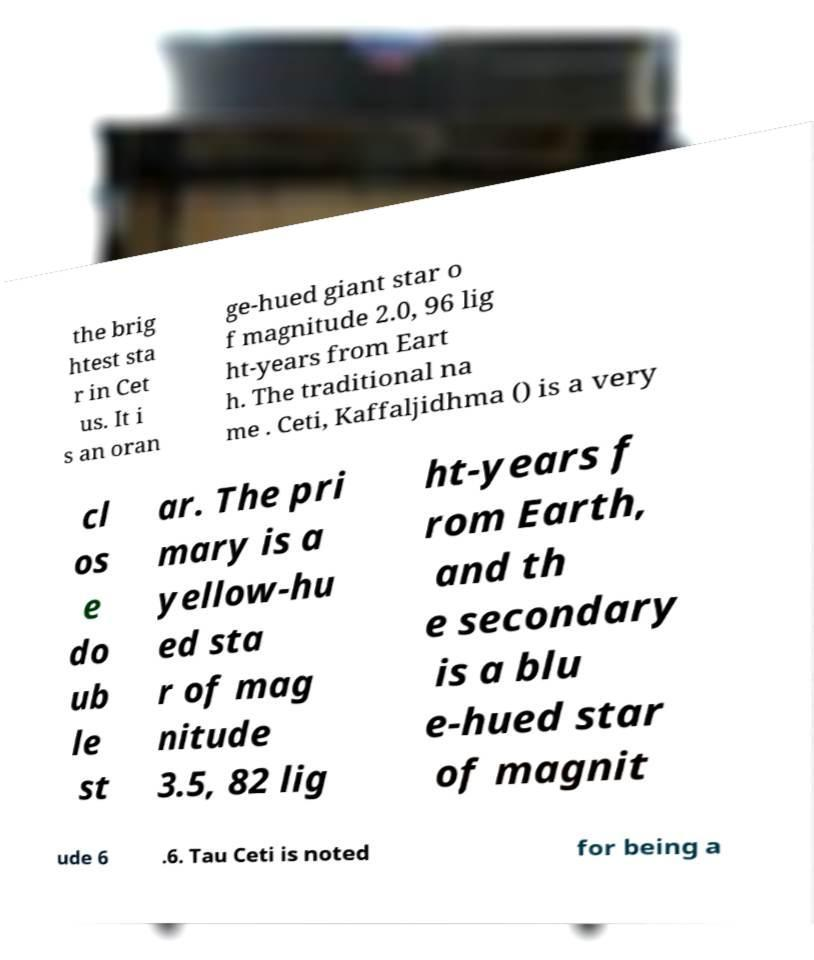Could you extract and type out the text from this image? the brig htest sta r in Cet us. It i s an oran ge-hued giant star o f magnitude 2.0, 96 lig ht-years from Eart h. The traditional na me . Ceti, Kaffaljidhma () is a very cl os e do ub le st ar. The pri mary is a yellow-hu ed sta r of mag nitude 3.5, 82 lig ht-years f rom Earth, and th e secondary is a blu e-hued star of magnit ude 6 .6. Tau Ceti is noted for being a 